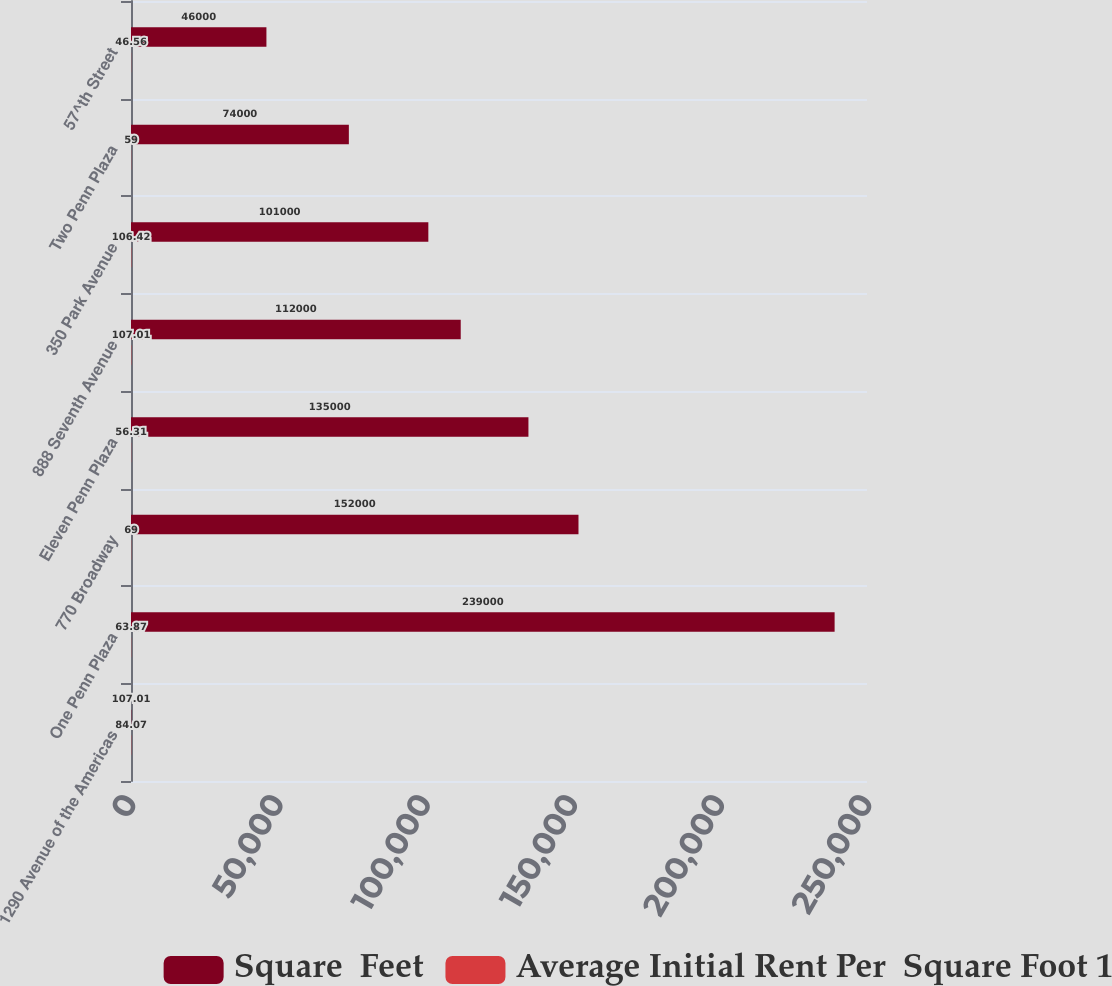Convert chart. <chart><loc_0><loc_0><loc_500><loc_500><stacked_bar_chart><ecel><fcel>1290 Avenue of the Americas<fcel>One Penn Plaza<fcel>770 Broadway<fcel>Eleven Penn Plaza<fcel>888 Seventh Avenue<fcel>350 Park Avenue<fcel>Two Penn Plaza<fcel>57^th Street<nl><fcel>Square  Feet<fcel>107.01<fcel>239000<fcel>152000<fcel>135000<fcel>112000<fcel>101000<fcel>74000<fcel>46000<nl><fcel>Average Initial Rent Per  Square Foot 1<fcel>84.07<fcel>63.87<fcel>69<fcel>56.31<fcel>107.01<fcel>106.42<fcel>59<fcel>46.56<nl></chart> 